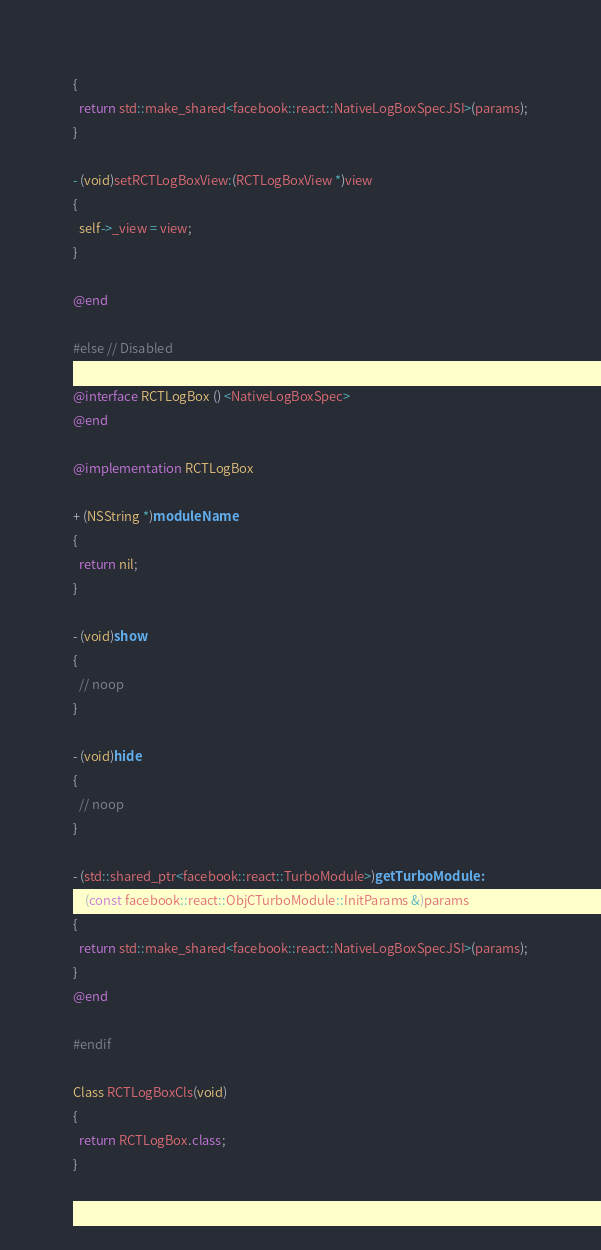Convert code to text. <code><loc_0><loc_0><loc_500><loc_500><_ObjectiveC_>{
  return std::make_shared<facebook::react::NativeLogBoxSpecJSI>(params);
}

- (void)setRCTLogBoxView:(RCTLogBoxView *)view
{
  self->_view = view;
}

@end

#else // Disabled

@interface RCTLogBox () <NativeLogBoxSpec>
@end

@implementation RCTLogBox

+ (NSString *)moduleName
{
  return nil;
}

- (void)show
{
  // noop
}

- (void)hide
{
  // noop
}

- (std::shared_ptr<facebook::react::TurboModule>)getTurboModule:
    (const facebook::react::ObjCTurboModule::InitParams &)params
{
  return std::make_shared<facebook::react::NativeLogBoxSpecJSI>(params);
}
@end

#endif

Class RCTLogBoxCls(void)
{
  return RCTLogBox.class;
}
</code> 